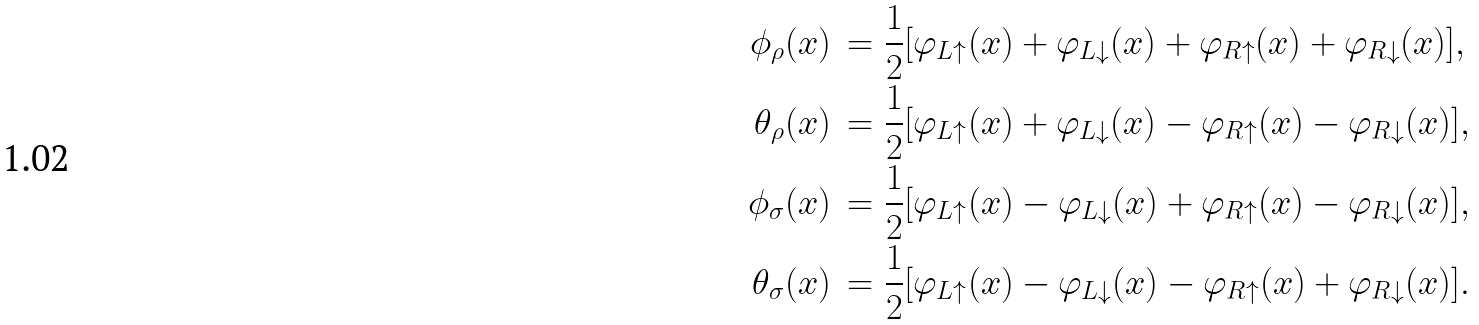Convert formula to latex. <formula><loc_0><loc_0><loc_500><loc_500>\phi _ { \rho } ( x ) & \, = \frac { 1 } { 2 } [ \varphi _ { L \uparrow } ( x ) + \varphi _ { L \downarrow } ( x ) + \varphi _ { R \uparrow } ( x ) + \varphi _ { R \downarrow } ( x ) ] , \\ \theta _ { \rho } ( x ) & \, = \frac { 1 } { 2 } [ \varphi _ { L \uparrow } ( x ) + \varphi _ { L \downarrow } ( x ) - \varphi _ { R \uparrow } ( x ) - \varphi _ { R \downarrow } ( x ) ] , \\ \phi _ { \sigma } ( x ) & \, = \frac { 1 } { 2 } [ \varphi _ { L \uparrow } ( x ) - \varphi _ { L \downarrow } ( x ) + \varphi _ { R \uparrow } ( x ) - \varphi _ { R \downarrow } ( x ) ] , \\ \theta _ { \sigma } ( x ) & \, = \frac { 1 } { 2 } [ \varphi _ { L \uparrow } ( x ) - \varphi _ { L \downarrow } ( x ) - \varphi _ { R \uparrow } ( x ) + \varphi _ { R \downarrow } ( x ) ] .</formula> 